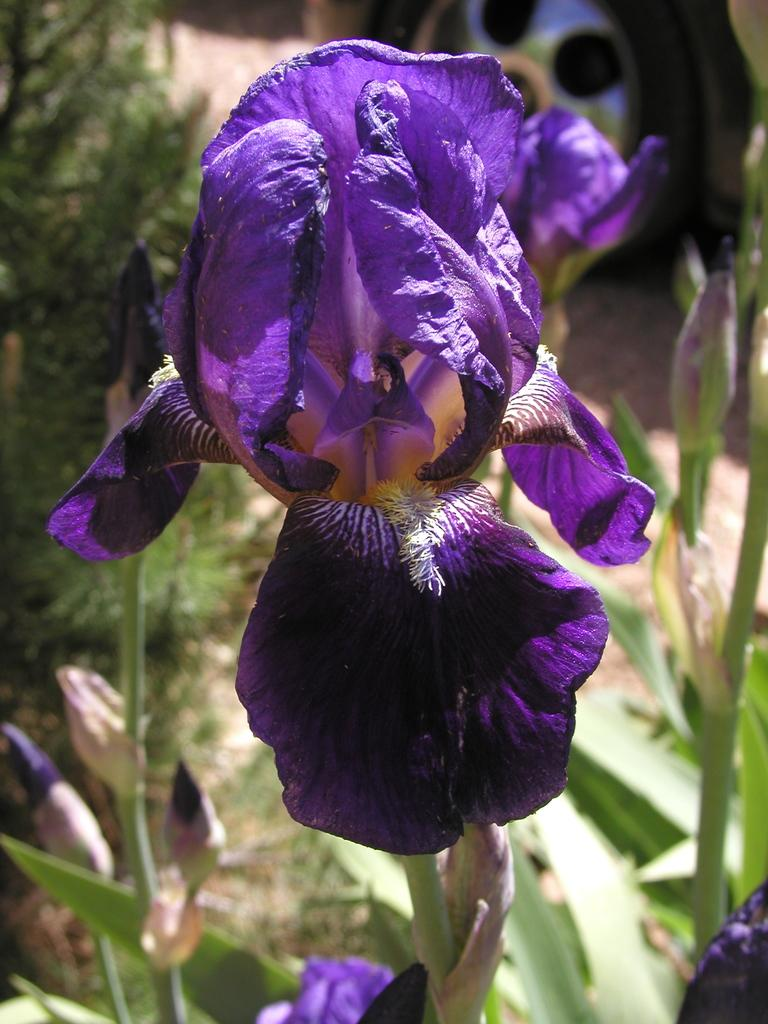What type of living organisms can be seen in the image? Plants can be seen in the image. Are there any specific features on the plants? Yes, there are flowers on at least one plant. What else is visible in the image? There is a vehicle at the top left side of the image. What type of patch can be seen on the actor's clothing in the image? There is no actor or clothing present in the image; it features plants and a vehicle. 